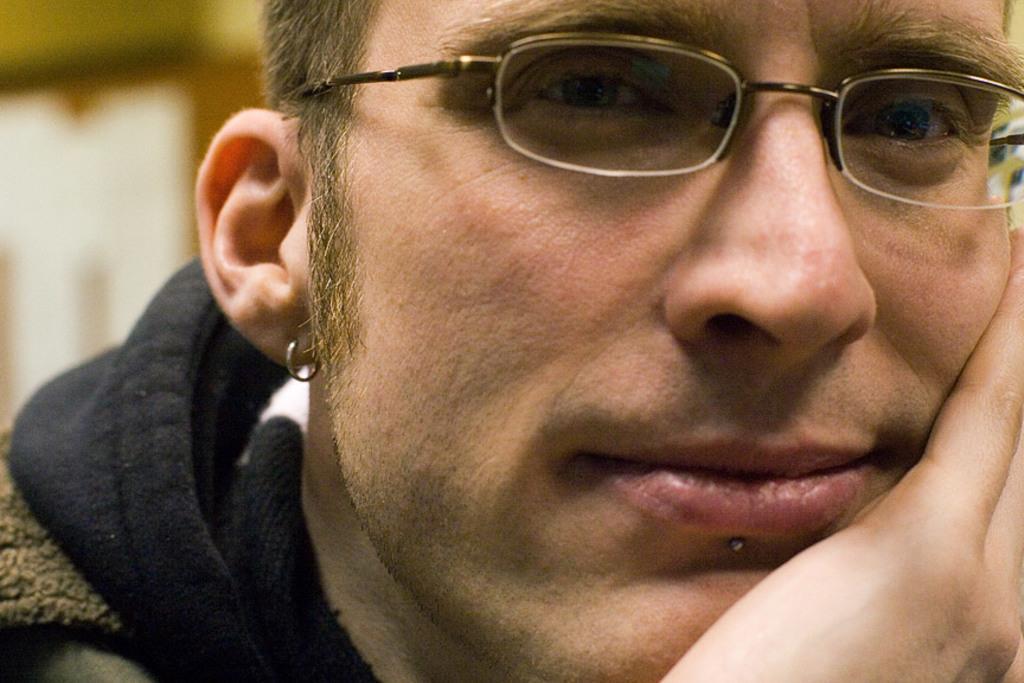Can you describe this image briefly? In this image we can see a person wearing spectacle and an earring in the image. There is a blur background at the left side of the image. 